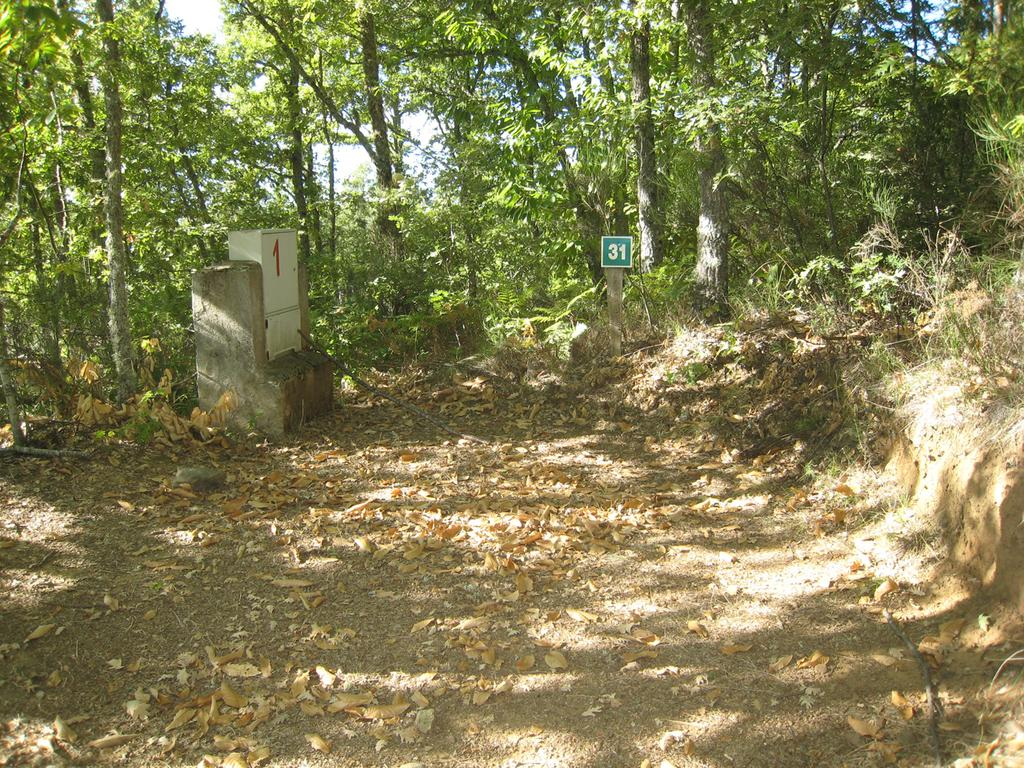What structure can be seen in the image? There is a pillar in the image. What is placed on the pillar? There is a box and a board on the pillar. What type of vegetation is visible in the image? There are trees and leaves in the image. What part of the natural environment is visible in the image? The sky is visible in the image. What type of drug can be seen in the image? There is no drug present in the image. How many pigs are visible in the image? There are no pigs present in the image. 